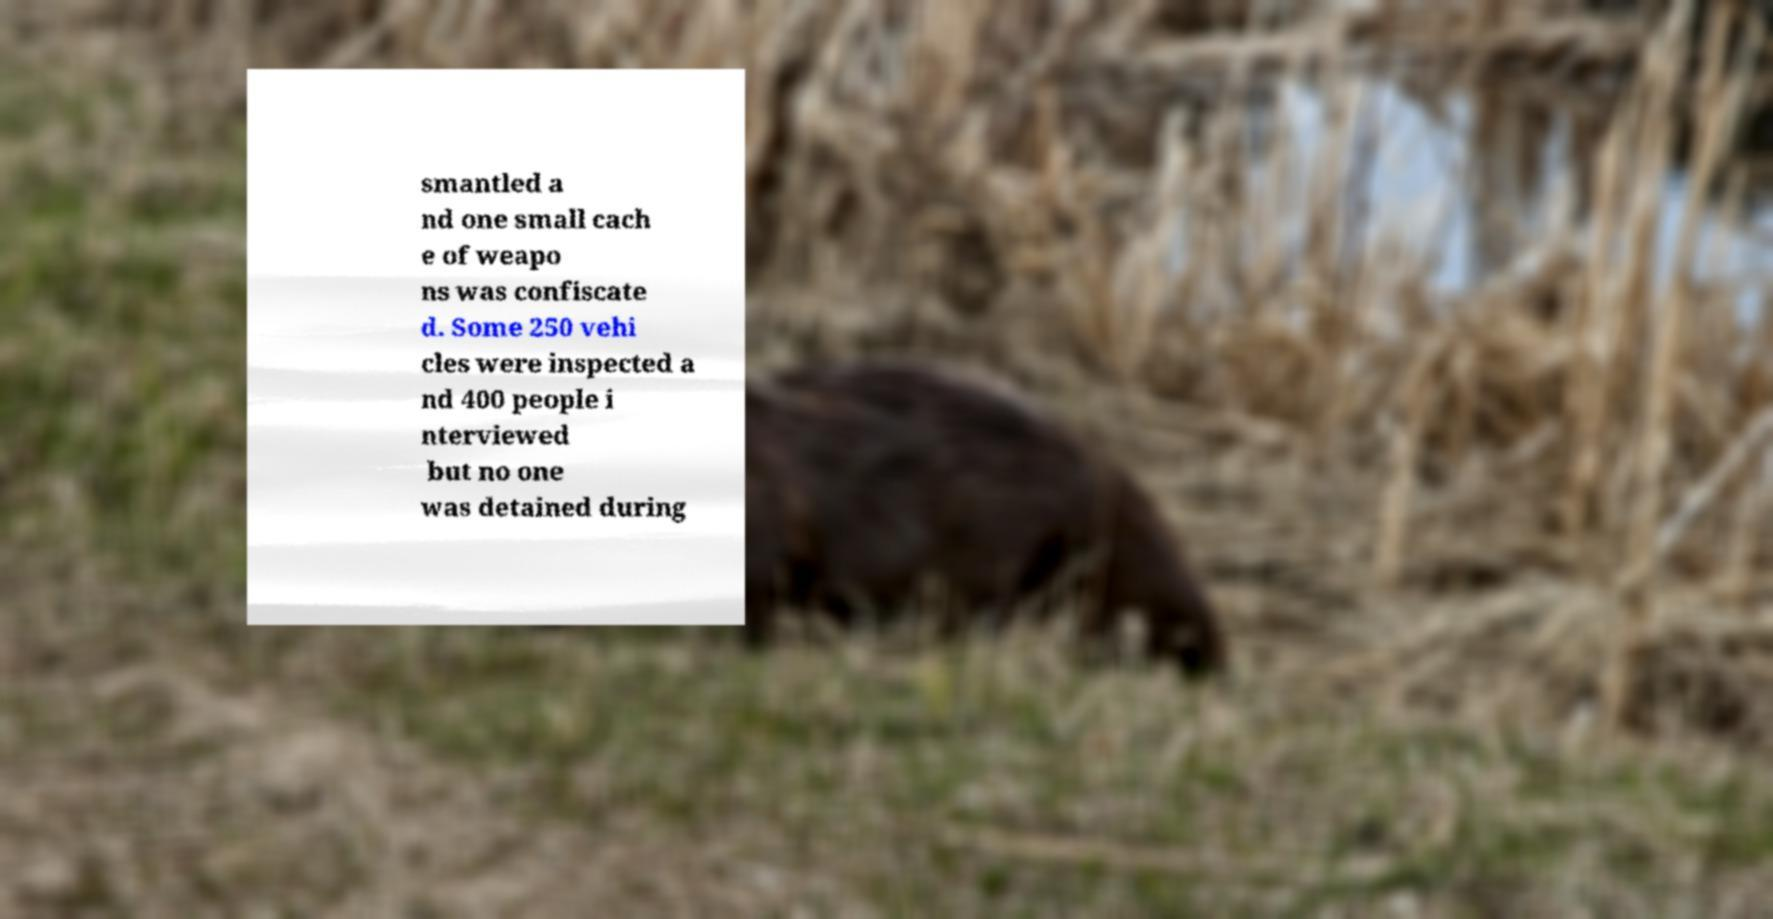Please identify and transcribe the text found in this image. smantled a nd one small cach e of weapo ns was confiscate d. Some 250 vehi cles were inspected a nd 400 people i nterviewed but no one was detained during 